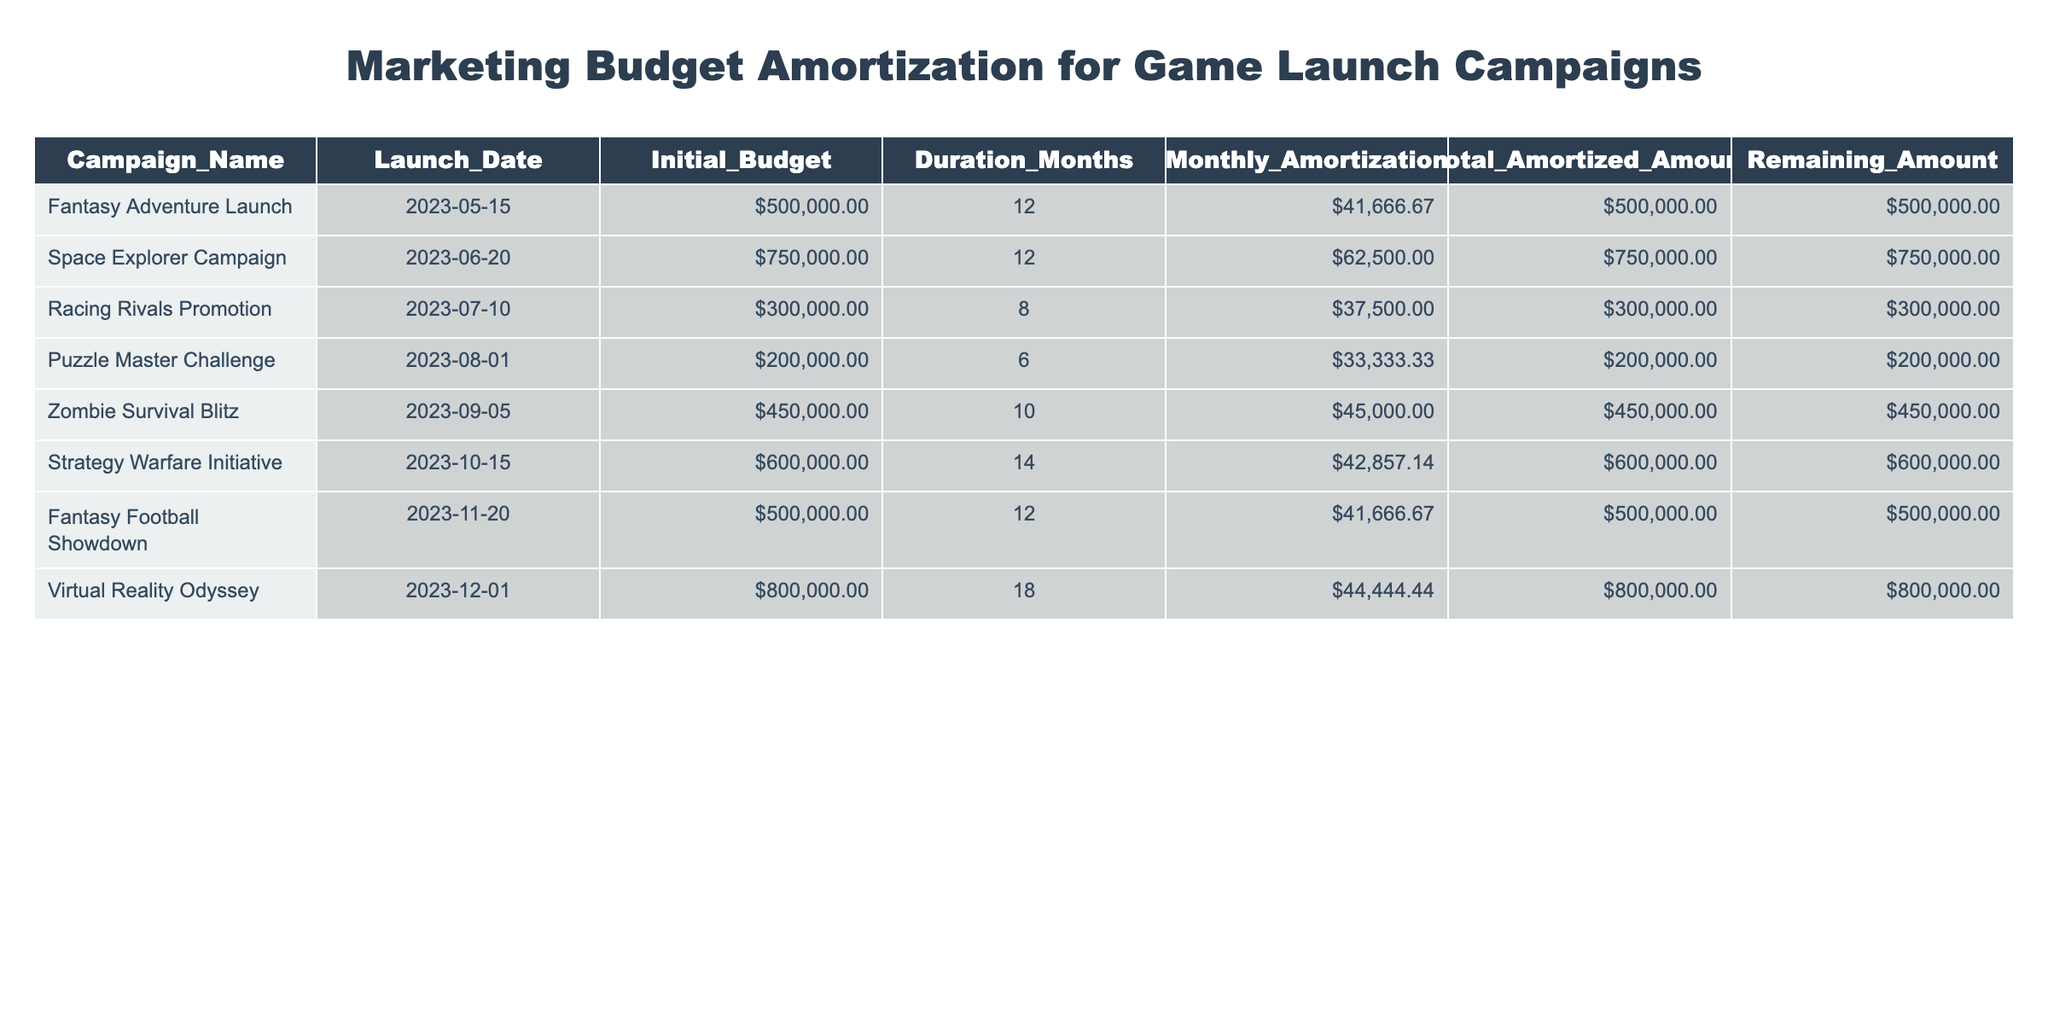What is the Initial Budget for the "Zombie Survival Blitz" campaign? The table lists the "Zombie Survival Blitz" campaign and shows that the Initial Budget is $450,000.
Answer: $450,000 How many months is the "Racing Rivals Promotion" planned for? The "Racing Rivals Promotion" campaign has a Duration of 8 Months according to the table.
Answer: 8 Months What is the total amount amortized for the "Virtual Reality Odyssey" campaign? The "Virtual Reality Odyssey" campaign has a Total Amortized Amount of $800,000 as indicated in the table.
Answer: $800,000 Is the Monthly Amortization for the "Space Explorer Campaign" more than $60,000? The Monthly Amortization for the "Space Explorer Campaign" is $62,500, which is greater than $60,000.
Answer: Yes What is the combined Initial Budget for all campaigns that have a duration of less than or equal to 10 months? The campaigns with a duration of less than or equal to 10 months are: "Racing Rivals Promotion" ($300,000), "Puzzle Master Challenge" ($200,000), "Zombie Survival Blitz" ($450,000), totaling $300,000 + $200,000 + $450,000 = $950,000.
Answer: $950,000 How much budget remains for the "Strategy Warfare Initiative"? The table shows that the Remaining Amount for the "Strategy Warfare Initiative" is $600,000.
Answer: $600,000 What is the average Monthly Amortization across all campaigns? To find the average, sum the Monthly Amortization values: $41,666.67 + $62,500 + $37,500 + $33,333.33 + $45,000 + $42,857.14 + $41,666.67 + $44,444.44 = $408,333.33. Divide by 8 campaigns yields $51,041.67 as the average.
Answer: $51,041.67 Which campaign has the highest Initial Budget, and what is that budget? The campaign with the highest Initial Budget is the "Virtual Reality Odyssey" with an Initial Budget of $800,000, which can be seen in the table as the greatest value in that column.
Answer: "Virtual Reality Odyssey", $800,000 Are there any campaigns that have a Remaining Amount less than $300,000? The table shows that all campaigns have Remaining Amounts greater than or equal to $300,000; hence there are no campaigns with less.
Answer: No 